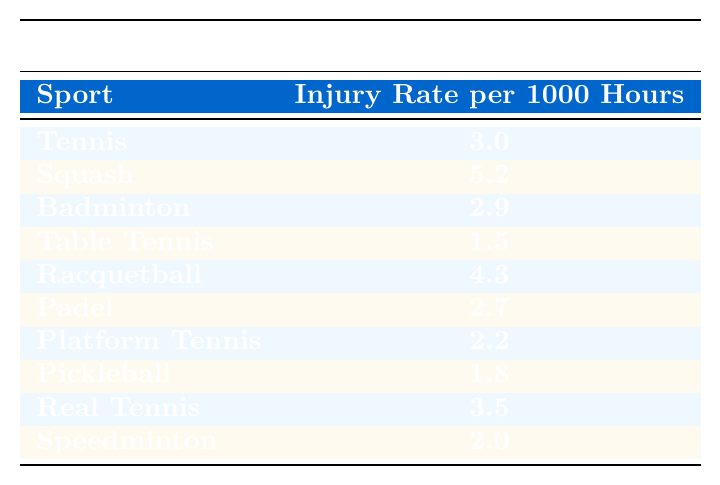What's the injury rate for Table Tennis? The injury rate for Table Tennis can be directly found in the table under the corresponding sport. It states the injury rate is 1.5 per 1000 hours.
Answer: 1.5 Which sport has the highest injury rate? By examining the values in the table, Squash has the highest injury rate at 5.2 per 1000 hours, which is greater than all other sports listed.
Answer: Squash What's the average injury rate for all the sports listed in the table? First, we sum all the injury rates: (3.0 + 5.2 + 2.9 + 1.5 + 4.3 + 2.7 + 2.2 + 1.8 + 3.5 + 2.0) = 25.1. There are 10 sports total, so we divide the sum by 10 to get the average: 25.1 / 10 = 2.51.
Answer: 2.51 Is the injury rate for Racquetball greater than that for Padel? The table shows that Racquetball has an injury rate of 4.3 and Padel has a rate of 2.7. Since 4.3 is greater than 2.7, the statement is true.
Answer: Yes How much higher is the injury rate for Squash compared to Badminton? The injury rate for Squash is 5.2, while Badminton has a rate of 2.9. To find the difference, we subtract the two: 5.2 - 2.9 = 2.3, indicating Squash's rate is 2.3 higher.
Answer: 2.3 Are there any sports with an injury rate lower than 2.0? In the table, we see that the lowest injury rate is for Table Tennis at 1.5 and Pickleball at 1.8, both of which are below 2.0. Thus, there are sports with lower rates than 2.0.
Answer: Yes What is the difference between the highest and lowest injury rates? The highest injury rate is 5.2 (Squash) and the lowest is 1.5 (Table Tennis). Calculating the difference, we get: 5.2 - 1.5 = 3.7.
Answer: 3.7 If you were to combine the injury rates for Real Tennis and Speedminton, what would the total be? Real Tennis has an injury rate of 3.5 and Speedminton has 2.0. We add them together: 3.5 + 2.0 = 5.5 for the combined total.
Answer: 5.5 Is the injury rate for Tennis less than the average injury rate of the sports listed? The average injury rate, calculated earlier as 2.51, is compared to Tennis's injury rate of 3.0. Since 3.0 is greater than 2.51, the statement is false.
Answer: No Which has a higher injury rate: Pickleball or Platform Tennis? Pickleball has an injury rate of 1.8 and Platform Tennis has 2.2. Since 2.2 is higher than 1.8, Platform Tennis has a greater injury rate.
Answer: Platform Tennis 